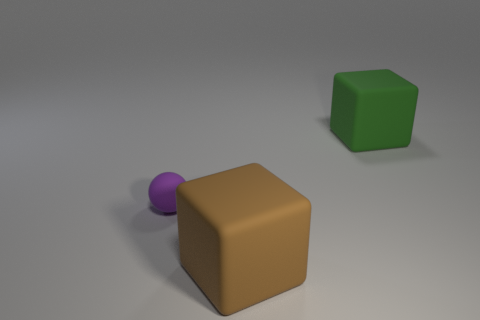The other rubber thing that is the same shape as the large green object is what color?
Ensure brevity in your answer.  Brown. Are there any other things that have the same shape as the large brown matte thing?
Offer a terse response. Yes. Are there an equal number of small balls on the right side of the big green block and large green blocks?
Keep it short and to the point. No. How many rubber things are on the right side of the small matte thing and behind the big brown object?
Keep it short and to the point. 1. The brown rubber object that is the same shape as the green rubber object is what size?
Offer a very short reply. Large. What number of large blocks are made of the same material as the green object?
Keep it short and to the point. 1. Are there fewer small spheres right of the big brown rubber thing than small gray shiny cylinders?
Offer a terse response. No. What number of cyan metallic cylinders are there?
Ensure brevity in your answer.  0. Is the shape of the large green matte thing the same as the brown matte object?
Offer a terse response. Yes. There is a block that is in front of the matte object behind the matte ball; what size is it?
Make the answer very short. Large. 